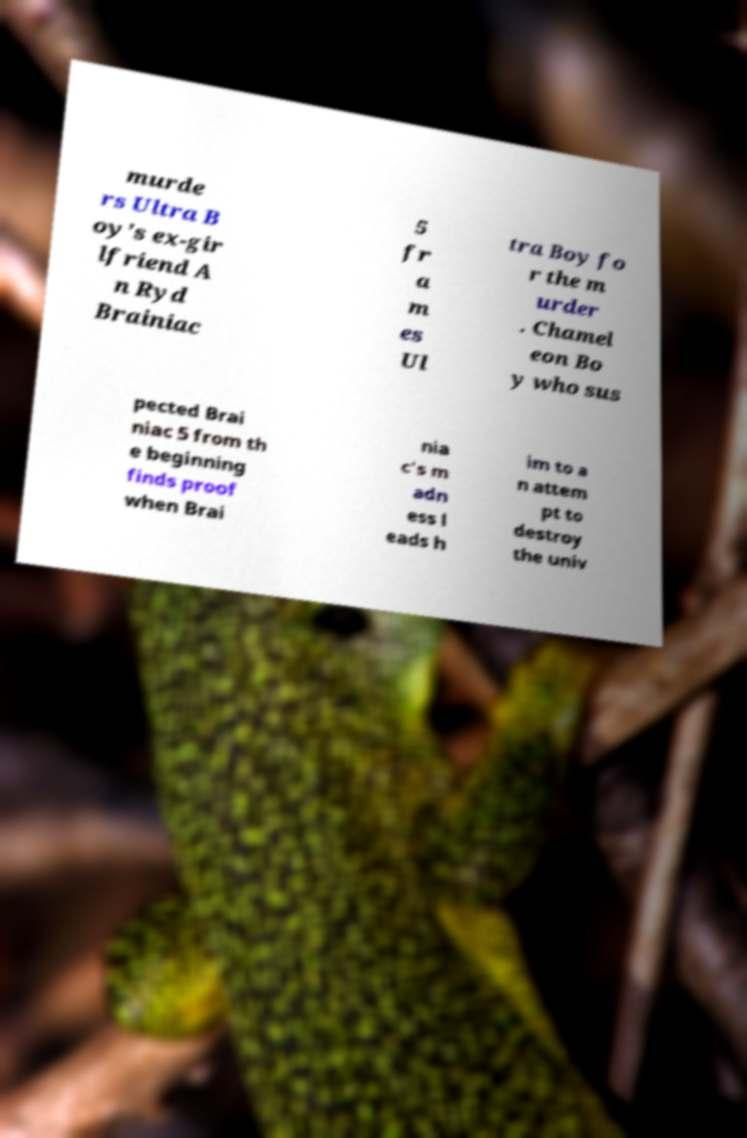Please identify and transcribe the text found in this image. murde rs Ultra B oy's ex-gir lfriend A n Ryd Brainiac 5 fr a m es Ul tra Boy fo r the m urder . Chamel eon Bo y who sus pected Brai niac 5 from th e beginning finds proof when Brai nia c's m adn ess l eads h im to a n attem pt to destroy the univ 